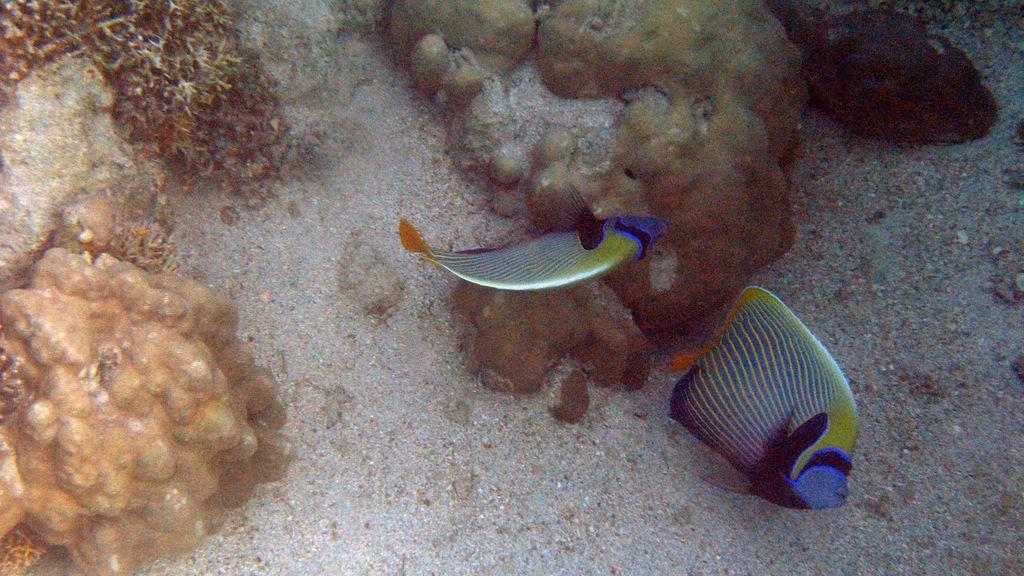Please provide a concise description of this image. I think this picture is taken under the ocean. In the center, there are two fishes which are in different colors. On the top, there are stones and plants. 